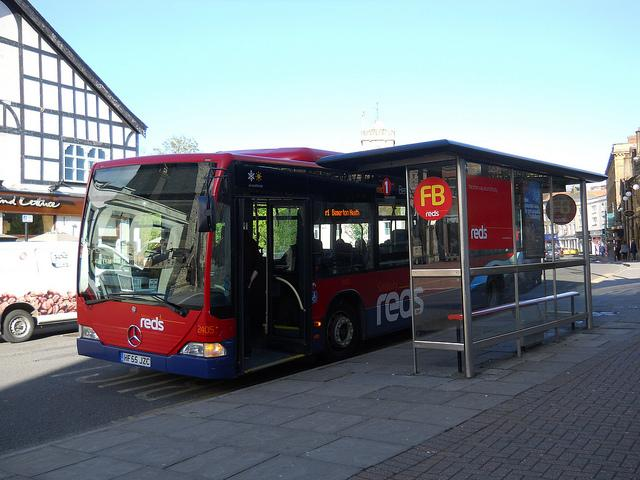What reason is the glass structure placed here? bus stop 